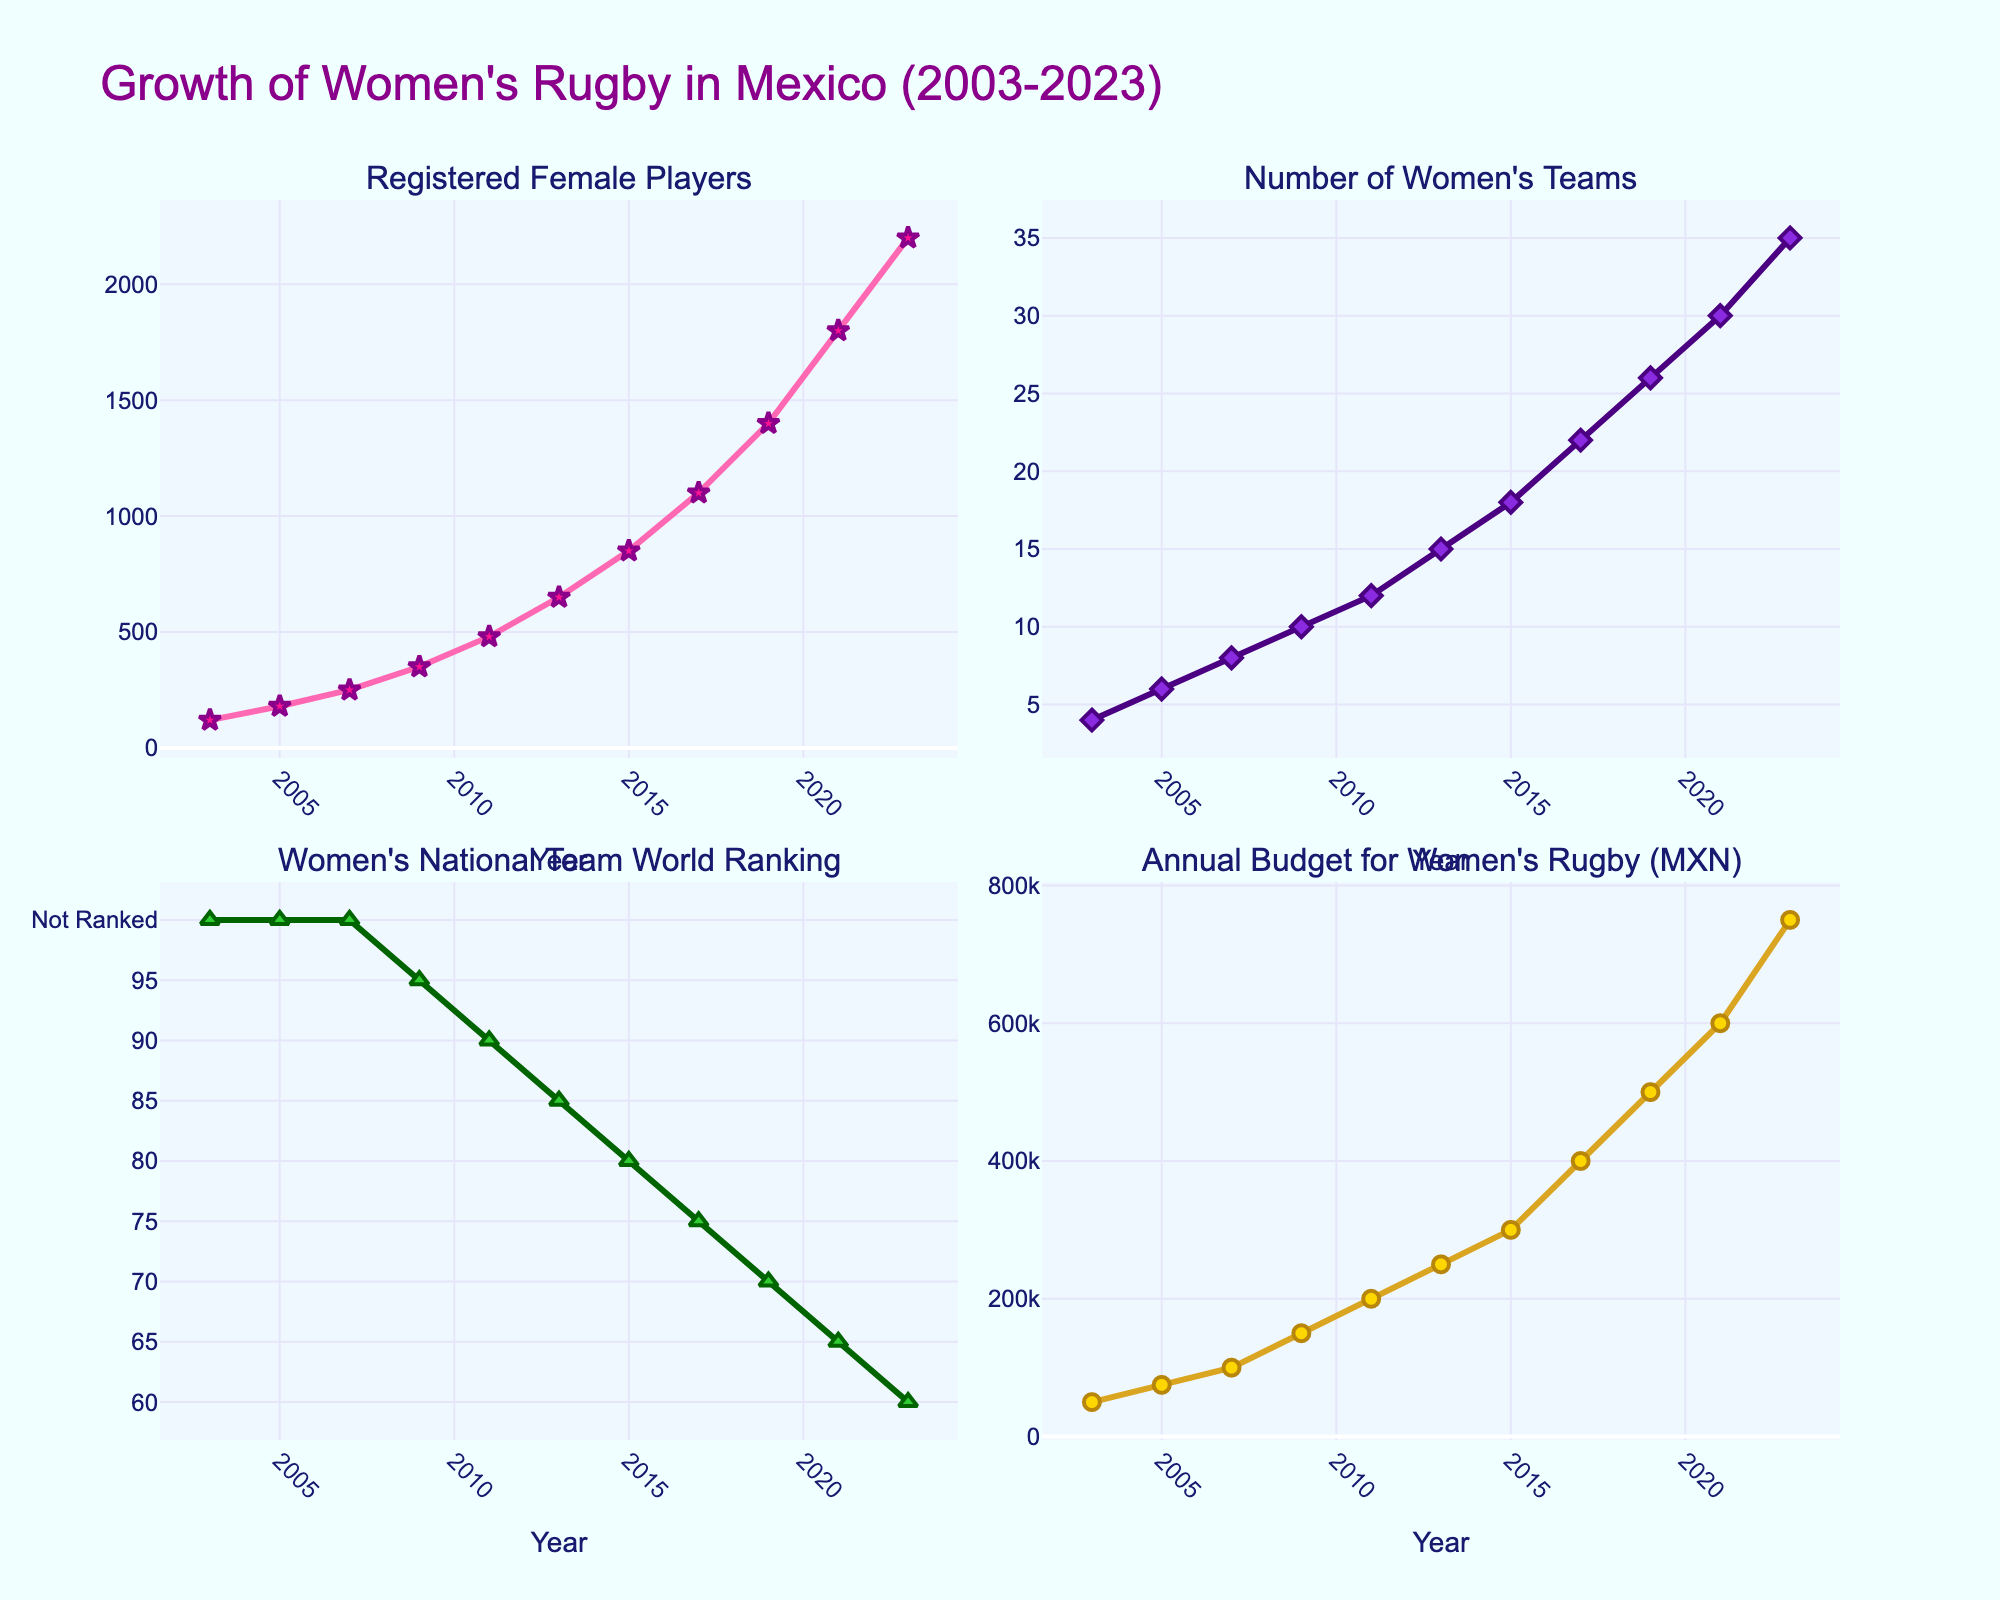what is the change in the number of registered female players between 2009 and 2013? To find the change, subtract the number of registered female players in 2009 from the number in 2013. So, 650 (2013) - 350 (2009) = 300.
Answer: 300 Between which consecutive years did the number of women's teams grow the most? Compare the differences between consecutive years for the number of women's teams. The largest difference is between 2017 and 2019 where it grew from 22 to 26, which is a difference of 4 teams.
Answer: 2017-2019 Which year shows the lowest world ranking for the women's national team? Look at the world ranking subplot and find the year with the lowest numerical value, as lower numbers indicate better ranking. The year is 2023 with a rank of 60.
Answer: 2023 In what range did the annual budget for women's rugby increase the most? Calculate the differences in the annual budget between consecutive points, then identify the largest difference. The budget increased the most between 2011 and 2013 (250,000 - 200,000 = 50,000 MXN).
Answer: 2011-2013 Which line shows the most consistent upward trend across all years? Assess the overall trend in all subplots. The 'Annual Budget for Women's Rugby' shows a consistent upward trend with no dips or flat periods.
Answer: Annual Budget How many teams were there when the number of registered female players reached 1800? Locate the point on the 'Registered Female Players' subplot where the value is 1800 (Year 2021). Then cross-reference this point with the 'Number of Women's Teams' subplot, which shows 30 teams.
Answer: 30 Compare the woman's national team's world ranking's overall trend with the number of registered female players? The world ranking plot shows a decreasing trend (improving rankings, since lower is better) while the number of registered female players displays an increasing trend.
Answer: Opposite trends What was the average annual budget for women's rugby from 2011 to 2015? Sum the annual budgets from 2011 to 2015 and divide by the number of years. (200,000 + 250,000 + 300,000)/3 = 250,000 MXN.
Answer: 250,000 MXN What is the relationship between the national team's world ranking and the annual budget for women's rugby from 2009 to 2023? During this period, the world ranking decreases (improves) as the annual budget increases, suggesting better funding may be tied to a better world ranking.
Answer: Inverse relationship 